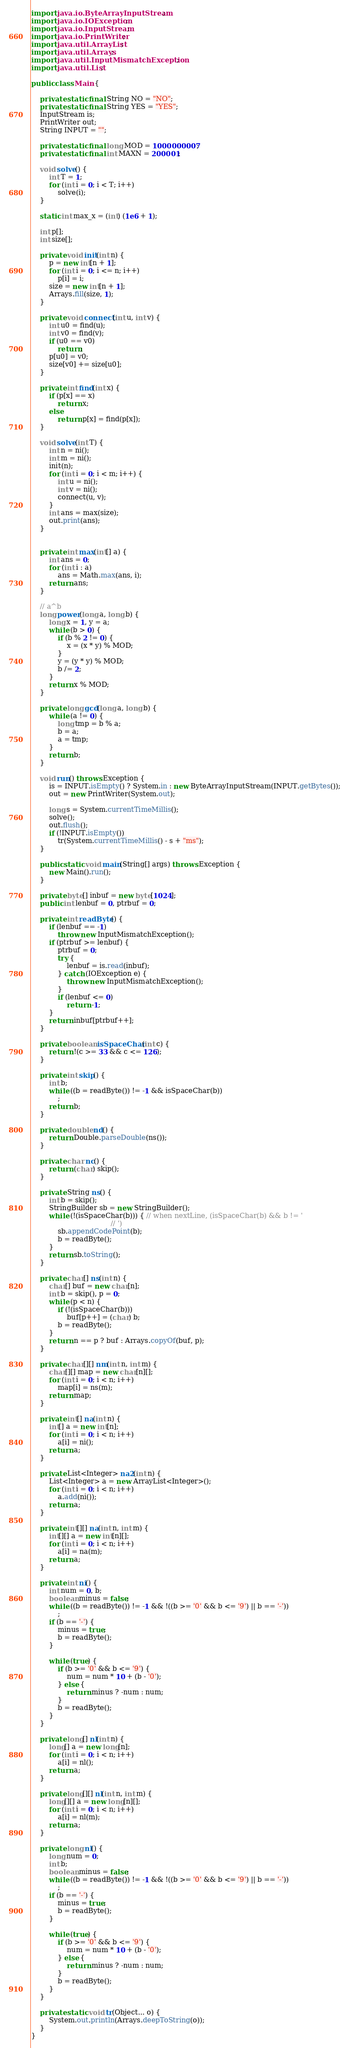<code> <loc_0><loc_0><loc_500><loc_500><_Java_>import java.io.ByteArrayInputStream;
import java.io.IOException;
import java.io.InputStream;
import java.io.PrintWriter;
import java.util.ArrayList;
import java.util.Arrays;
import java.util.InputMismatchException;
import java.util.List;

public class Main {

	private static final String NO = "NO";
	private static final String YES = "YES";
	InputStream is;
	PrintWriter out;
	String INPUT = "";

	private static final long MOD = 1000000007;
	private static final int MAXN = 200001;

	void solve() {
		int T = 1;
		for (int i = 0; i < T; i++)
			solve(i);
	}

	static int max_x = (int) (1e6 + 1);

	int p[];
	int size[];

	private void init(int n) {
		p = new int[n + 1];
		for (int i = 0; i <= n; i++)
			p[i] = i;
		size = new int[n + 1];
		Arrays.fill(size, 1);
	}
	
	private void connect(int u, int v) {
		int u0 = find(u);
		int v0 = find(v);
		if (u0 == v0)
			return;
		p[u0] = v0;
		size[v0] += size[u0];
	}

	private int find(int x) {
		if (p[x] == x)
			return x;
		else
			return p[x] = find(p[x]);
	}

	void solve(int T) {
		int n = ni();
		int m = ni();
		init(n);
		for (int i = 0; i < m; i++) {
			int u = ni();
			int v = ni();
			connect(u, v);
		}
		int ans = max(size);
		out.print(ans);
	}


	private int max(int[] a) {
		int ans = 0;
		for (int i : a)
			ans = Math.max(ans, i);
		return ans;
	}

	// a^b
	long power(long a, long b) {
		long x = 1, y = a;
		while (b > 0) {
			if (b % 2 != 0) {
				x = (x * y) % MOD;
			}
			y = (y * y) % MOD;
			b /= 2;
		}
		return x % MOD;
	}

	private long gcd(long a, long b) {
		while (a != 0) {
			long tmp = b % a;
			b = a;
			a = tmp;
		}
		return b;
	}

	void run() throws Exception {
		is = INPUT.isEmpty() ? System.in : new ByteArrayInputStream(INPUT.getBytes());
		out = new PrintWriter(System.out);

		long s = System.currentTimeMillis();
		solve();
		out.flush();
		if (!INPUT.isEmpty())
			tr(System.currentTimeMillis() - s + "ms");
	}

	public static void main(String[] args) throws Exception {
		new Main().run();
	}

	private byte[] inbuf = new byte[1024];
	public int lenbuf = 0, ptrbuf = 0;

	private int readByte() {
		if (lenbuf == -1)
			throw new InputMismatchException();
		if (ptrbuf >= lenbuf) {
			ptrbuf = 0;
			try {
				lenbuf = is.read(inbuf);
			} catch (IOException e) {
				throw new InputMismatchException();
			}
			if (lenbuf <= 0)
				return -1;
		}
		return inbuf[ptrbuf++];
	}

	private boolean isSpaceChar(int c) {
		return !(c >= 33 && c <= 126);
	}

	private int skip() {
		int b;
		while ((b = readByte()) != -1 && isSpaceChar(b))
			;
		return b;
	}

	private double nd() {
		return Double.parseDouble(ns());
	}

	private char nc() {
		return (char) skip();
	}

	private String ns() {
		int b = skip();
		StringBuilder sb = new StringBuilder();
		while (!(isSpaceChar(b))) { // when nextLine, (isSpaceChar(b) && b != '
									// ')
			sb.appendCodePoint(b);
			b = readByte();
		}
		return sb.toString();
	}

	private char[] ns(int n) {
		char[] buf = new char[n];
		int b = skip(), p = 0;
		while (p < n) {
			if (!(isSpaceChar(b)))
				buf[p++] = (char) b;
			b = readByte();
		}
		return n == p ? buf : Arrays.copyOf(buf, p);
	}

	private char[][] nm(int n, int m) {
		char[][] map = new char[n][];
		for (int i = 0; i < n; i++)
			map[i] = ns(m);
		return map;
	}

	private int[] na(int n) {
		int[] a = new int[n];
		for (int i = 0; i < n; i++)
			a[i] = ni();
		return a;
	}

	private List<Integer> na2(int n) {
		List<Integer> a = new ArrayList<Integer>();
		for (int i = 0; i < n; i++)
			a.add(ni());
		return a;
	}

	private int[][] na(int n, int m) {
		int[][] a = new int[n][];
		for (int i = 0; i < n; i++)
			a[i] = na(m);
		return a;
	}

	private int ni() {
		int num = 0, b;
		boolean minus = false;
		while ((b = readByte()) != -1 && !((b >= '0' && b <= '9') || b == '-'))
			;
		if (b == '-') {
			minus = true;
			b = readByte();
		}

		while (true) {
			if (b >= '0' && b <= '9') {
				num = num * 10 + (b - '0');
			} else {
				return minus ? -num : num;
			}
			b = readByte();
		}
	}

	private long[] nl(int n) {
		long[] a = new long[n];
		for (int i = 0; i < n; i++)
			a[i] = nl();
		return a;
	}

	private long[][] nl(int n, int m) {
		long[][] a = new long[n][];
		for (int i = 0; i < n; i++)
			a[i] = nl(m);
		return a;
	}

	private long nl() {
		long num = 0;
		int b;
		boolean minus = false;
		while ((b = readByte()) != -1 && !((b >= '0' && b <= '9') || b == '-'))
			;
		if (b == '-') {
			minus = true;
			b = readByte();
		}

		while (true) {
			if (b >= '0' && b <= '9') {
				num = num * 10 + (b - '0');
			} else {
				return minus ? -num : num;
			}
			b = readByte();
		}
	}

	private static void tr(Object... o) {
		System.out.println(Arrays.deepToString(o));
	}
}</code> 